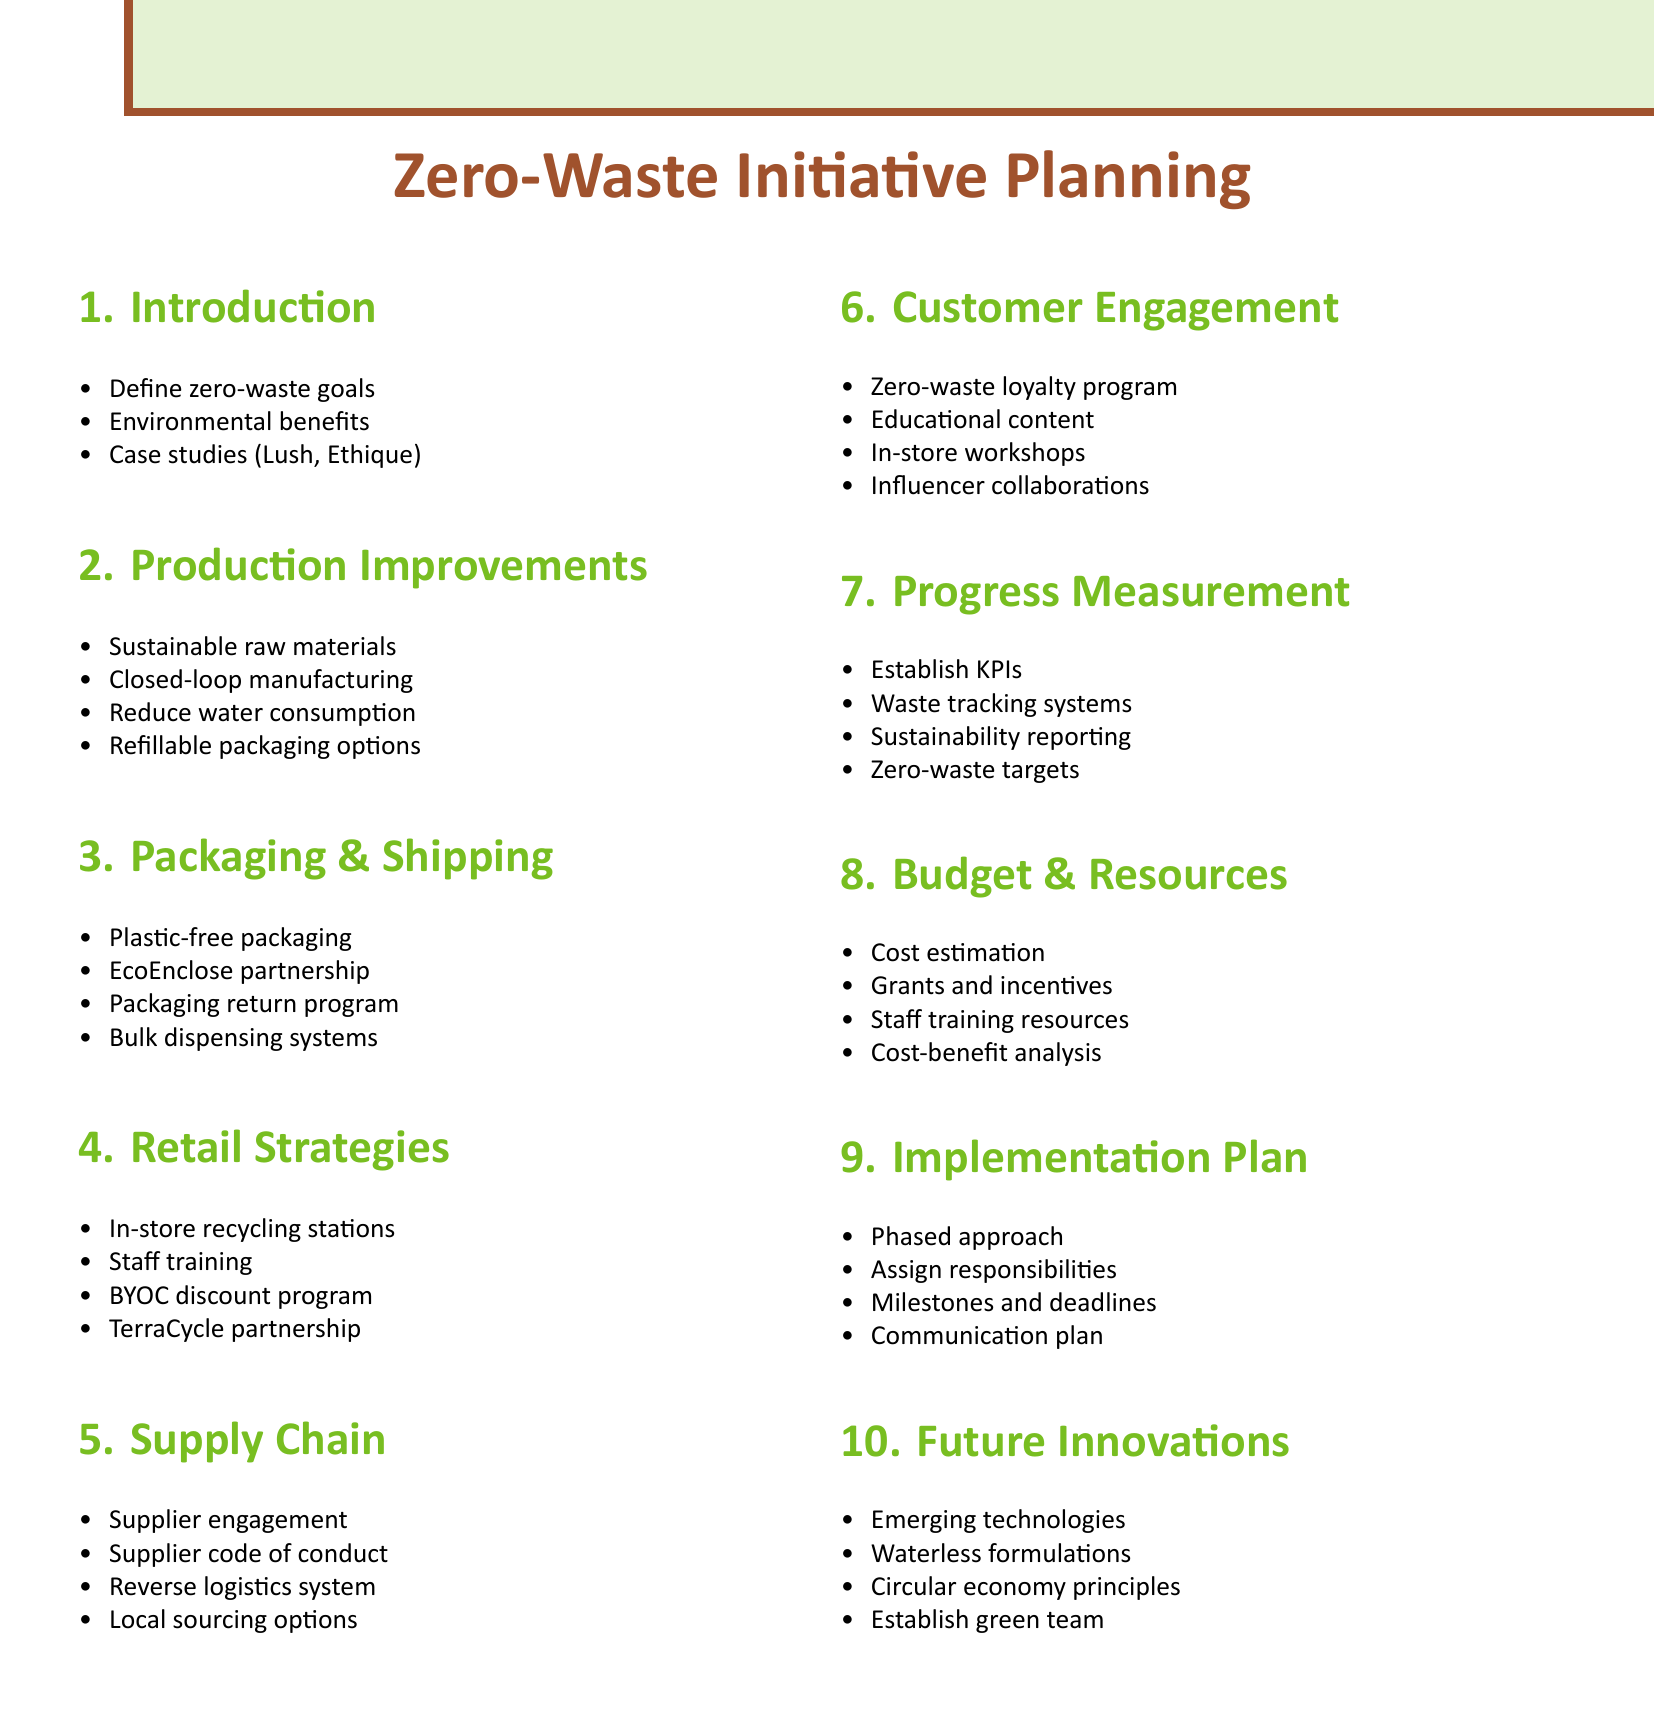What are the subtopics under "Introduction to Zero-Waste Initiative"? The subtopics relate to defining goals, highlighting benefits, and presenting case studies.
Answer: Define zero-waste goals for our organic skincare brand, Highlight environmental benefits of zero-waste practices, Present successful case studies (e.g., Lush Cosmetics, Ethique) What is one sustainable material mentioned in the production process improvements? The document suggests sourcing materials that support environmental sustainability.
Answer: Biodegradable raw materials What program is suggested to engage customers in zero-waste practices? The agenda includes promoting a program that encourages customer participation in zero-waste efforts.
Answer: Zero-waste loyalty program What is one of the roles of suppliers in the supply chain collaboration? The document mentions a degree of participation expected from suppliers concerning waste reduction efforts.
Answer: Engaging suppliers in zero-waste initiatives What is the purpose of the KPIs mentioned in the measuring and reporting progress section? KPIs help in evaluating effectiveness and tracking outcomes related to waste management.
Answer: Waste reduction What packaging strategy is emphasized in the packaging and shipping optimization section? The transition to new packaging types signifies a shift in how products are offered to customers.
Answer: Plastic-free, compostable packaging How many agenda items are listed in the document? The total number of major agenda items can be counted for clarity.
Answer: Ten What training is suggested for retail staff in relation to zero-waste? The document outlines educational support for staff, directly enhancing customer interactions.
Answer: Training staff on zero-waste practices and customer education What kind of analysis is included in the budget and resource allocation section? Financial evaluations are implicit in understanding the viability of the zero-waste initiatives.
Answer: Cost-benefit analysis 